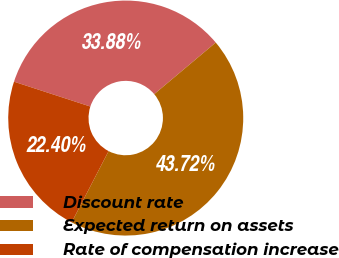<chart> <loc_0><loc_0><loc_500><loc_500><pie_chart><fcel>Discount rate<fcel>Expected return on assets<fcel>Rate of compensation increase<nl><fcel>33.88%<fcel>43.72%<fcel>22.4%<nl></chart> 